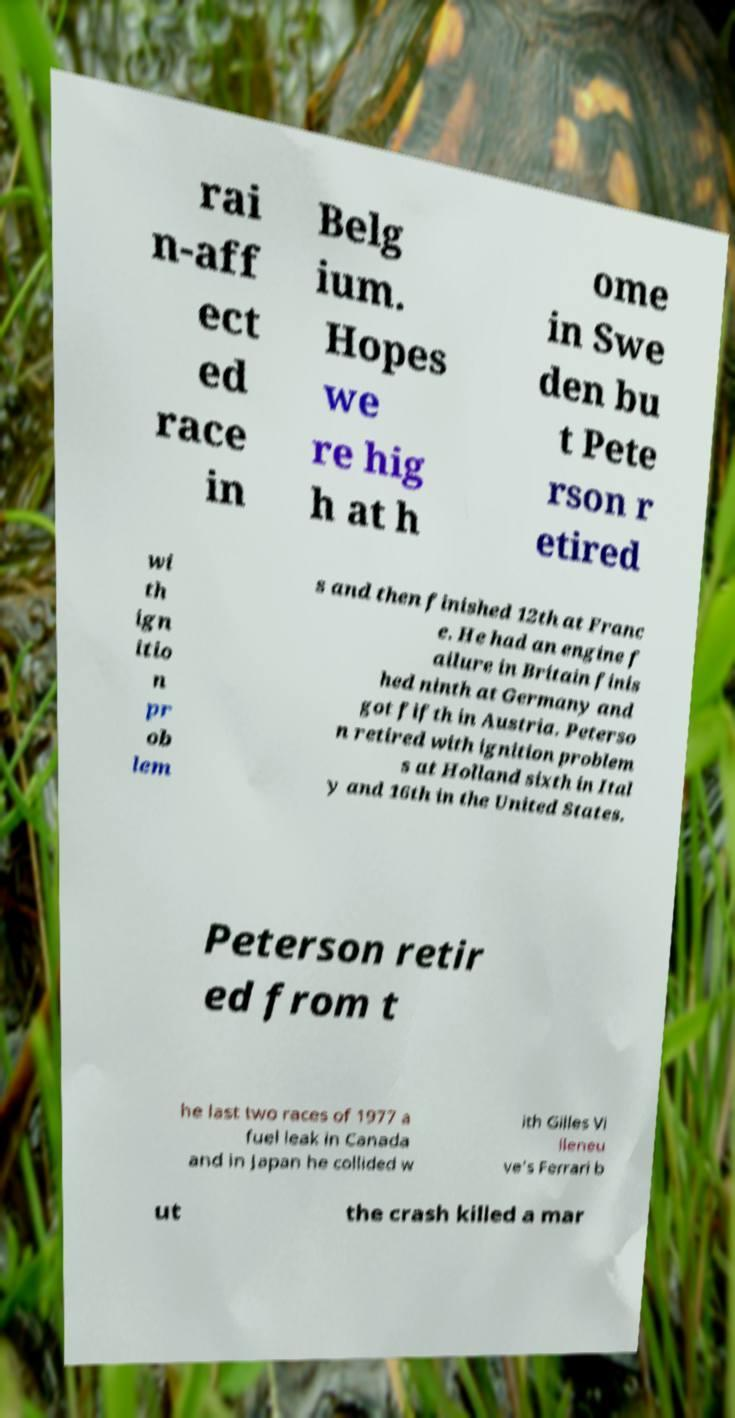Please read and relay the text visible in this image. What does it say? rai n-aff ect ed race in Belg ium. Hopes we re hig h at h ome in Swe den bu t Pete rson r etired wi th ign itio n pr ob lem s and then finished 12th at Franc e. He had an engine f ailure in Britain finis hed ninth at Germany and got fifth in Austria. Peterso n retired with ignition problem s at Holland sixth in Ital y and 16th in the United States. Peterson retir ed from t he last two races of 1977 a fuel leak in Canada and in Japan he collided w ith Gilles Vi lleneu ve's Ferrari b ut the crash killed a mar 